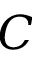<formula> <loc_0><loc_0><loc_500><loc_500>C</formula> 